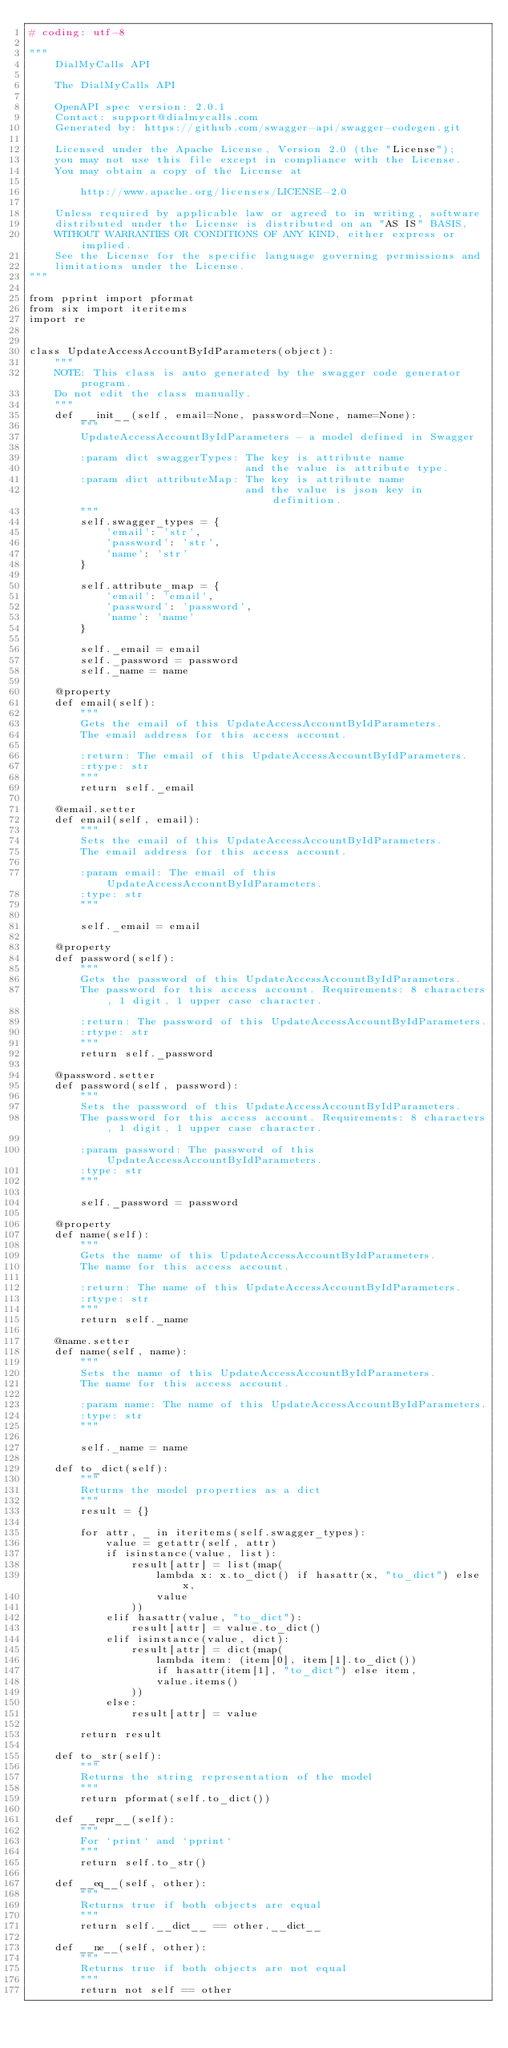Convert code to text. <code><loc_0><loc_0><loc_500><loc_500><_Python_># coding: utf-8

"""
    DialMyCalls API

    The DialMyCalls API

    OpenAPI spec version: 2.0.1
    Contact: support@dialmycalls.com
    Generated by: https://github.com/swagger-api/swagger-codegen.git

    Licensed under the Apache License, Version 2.0 (the "License");
    you may not use this file except in compliance with the License.
    You may obtain a copy of the License at

        http://www.apache.org/licenses/LICENSE-2.0

    Unless required by applicable law or agreed to in writing, software
    distributed under the License is distributed on an "AS IS" BASIS,
    WITHOUT WARRANTIES OR CONDITIONS OF ANY KIND, either express or implied.
    See the License for the specific language governing permissions and
    limitations under the License.
"""

from pprint import pformat
from six import iteritems
import re


class UpdateAccessAccountByIdParameters(object):
    """
    NOTE: This class is auto generated by the swagger code generator program.
    Do not edit the class manually.
    """
    def __init__(self, email=None, password=None, name=None):
        """
        UpdateAccessAccountByIdParameters - a model defined in Swagger

        :param dict swaggerTypes: The key is attribute name
                                  and the value is attribute type.
        :param dict attributeMap: The key is attribute name
                                  and the value is json key in definition.
        """
        self.swagger_types = {
            'email': 'str',
            'password': 'str',
            'name': 'str'
        }

        self.attribute_map = {
            'email': 'email',
            'password': 'password',
            'name': 'name'
        }

        self._email = email
        self._password = password
        self._name = name

    @property
    def email(self):
        """
        Gets the email of this UpdateAccessAccountByIdParameters.
        The email address for this access account.

        :return: The email of this UpdateAccessAccountByIdParameters.
        :rtype: str
        """
        return self._email

    @email.setter
    def email(self, email):
        """
        Sets the email of this UpdateAccessAccountByIdParameters.
        The email address for this access account.

        :param email: The email of this UpdateAccessAccountByIdParameters.
        :type: str
        """

        self._email = email

    @property
    def password(self):
        """
        Gets the password of this UpdateAccessAccountByIdParameters.
        The password for this access account. Requirements: 8 characters, 1 digit, 1 upper case character.

        :return: The password of this UpdateAccessAccountByIdParameters.
        :rtype: str
        """
        return self._password

    @password.setter
    def password(self, password):
        """
        Sets the password of this UpdateAccessAccountByIdParameters.
        The password for this access account. Requirements: 8 characters, 1 digit, 1 upper case character.

        :param password: The password of this UpdateAccessAccountByIdParameters.
        :type: str
        """

        self._password = password

    @property
    def name(self):
        """
        Gets the name of this UpdateAccessAccountByIdParameters.
        The name for this access account.

        :return: The name of this UpdateAccessAccountByIdParameters.
        :rtype: str
        """
        return self._name

    @name.setter
    def name(self, name):
        """
        Sets the name of this UpdateAccessAccountByIdParameters.
        The name for this access account.

        :param name: The name of this UpdateAccessAccountByIdParameters.
        :type: str
        """

        self._name = name

    def to_dict(self):
        """
        Returns the model properties as a dict
        """
        result = {}

        for attr, _ in iteritems(self.swagger_types):
            value = getattr(self, attr)
            if isinstance(value, list):
                result[attr] = list(map(
                    lambda x: x.to_dict() if hasattr(x, "to_dict") else x,
                    value
                ))
            elif hasattr(value, "to_dict"):
                result[attr] = value.to_dict()
            elif isinstance(value, dict):
                result[attr] = dict(map(
                    lambda item: (item[0], item[1].to_dict())
                    if hasattr(item[1], "to_dict") else item,
                    value.items()
                ))
            else:
                result[attr] = value

        return result

    def to_str(self):
        """
        Returns the string representation of the model
        """
        return pformat(self.to_dict())

    def __repr__(self):
        """
        For `print` and `pprint`
        """
        return self.to_str()

    def __eq__(self, other):
        """
        Returns true if both objects are equal
        """
        return self.__dict__ == other.__dict__

    def __ne__(self, other):
        """
        Returns true if both objects are not equal
        """
        return not self == other
</code> 